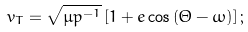<formula> <loc_0><loc_0><loc_500><loc_500>v _ { T } = \sqrt { \mu p ^ { - 1 } } \left [ 1 + e \cos \left ( \Theta - \omega \right ) \right ] ;</formula> 